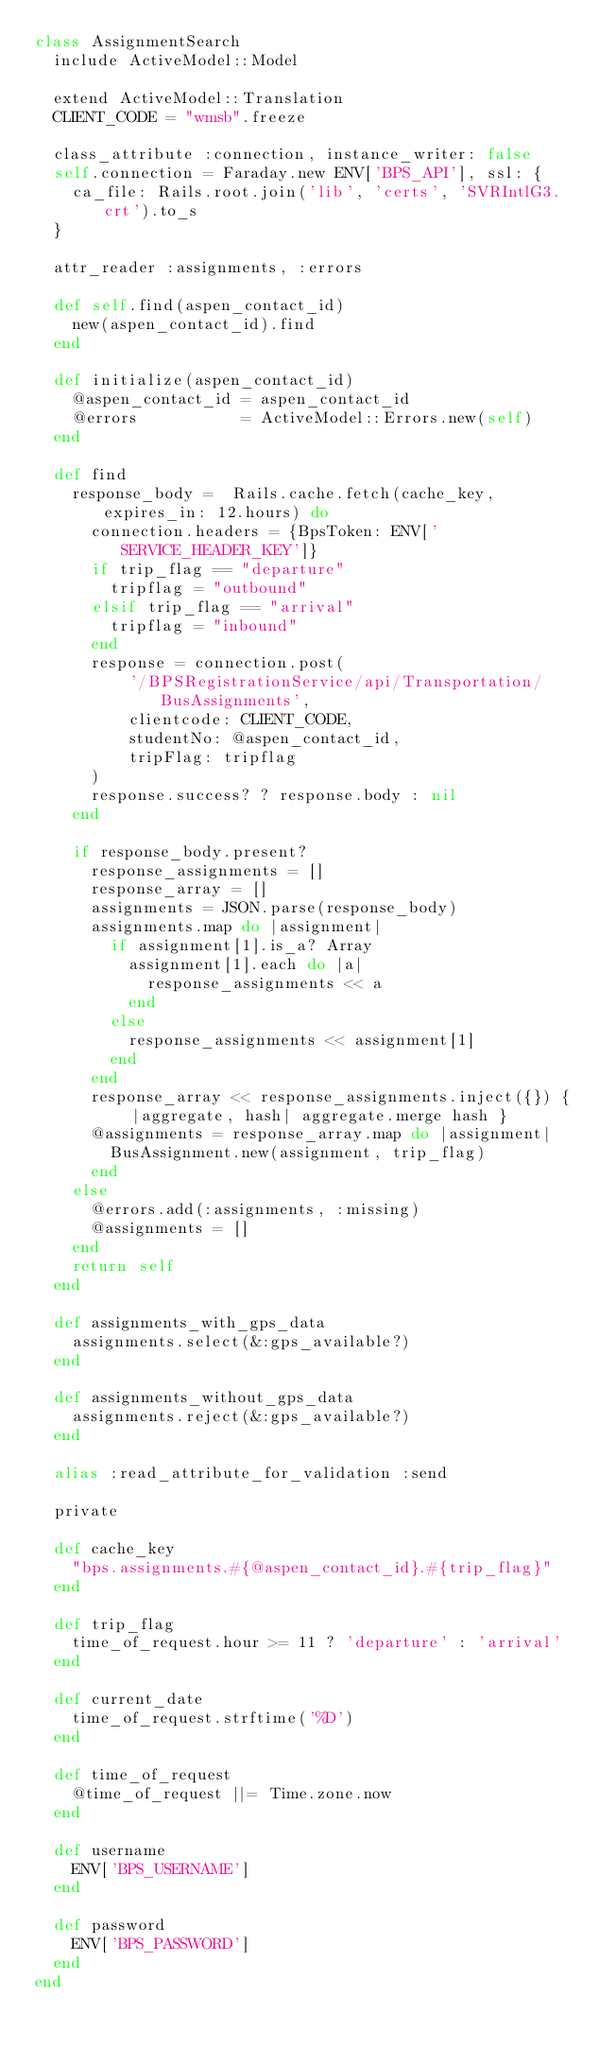Convert code to text. <code><loc_0><loc_0><loc_500><loc_500><_Ruby_>class AssignmentSearch
  include ActiveModel::Model

  extend ActiveModel::Translation
  CLIENT_CODE = "wmsb".freeze

  class_attribute :connection, instance_writer: false
  self.connection = Faraday.new ENV['BPS_API'], ssl: {
    ca_file: Rails.root.join('lib', 'certs', 'SVRIntlG3.crt').to_s
  }

  attr_reader :assignments, :errors

  def self.find(aspen_contact_id)
    new(aspen_contact_id).find
  end

  def initialize(aspen_contact_id)
    @aspen_contact_id = aspen_contact_id
    @errors           = ActiveModel::Errors.new(self)
  end

  def find
    response_body =  Rails.cache.fetch(cache_key, expires_in: 12.hours) do
      connection.headers = {BpsToken: ENV['SERVICE_HEADER_KEY']}
      if trip_flag == "departure"
        tripflag = "outbound"
      elsif trip_flag == "arrival"
        tripflag = "inbound"
      end
      response = connection.post(
          '/BPSRegistrationService/api/Transportation/BusAssignments',
          clientcode: CLIENT_CODE,
          studentNo: @aspen_contact_id,
          tripFlag: tripflag
      )
      response.success? ? response.body : nil
    end

    if response_body.present?
      response_assignments = []
      response_array = []
      assignments = JSON.parse(response_body)
      assignments.map do |assignment|
        if assignment[1].is_a? Array
          assignment[1].each do |a|
            response_assignments << a
          end
        else
          response_assignments << assignment[1]
        end
      end
      response_array << response_assignments.inject({}) { |aggregate, hash| aggregate.merge hash }
      @assignments = response_array.map do |assignment|
        BusAssignment.new(assignment, trip_flag)
      end
    else
      @errors.add(:assignments, :missing)
      @assignments = []
    end
    return self
  end

  def assignments_with_gps_data
    assignments.select(&:gps_available?)
  end

  def assignments_without_gps_data
    assignments.reject(&:gps_available?)
  end

  alias :read_attribute_for_validation :send

  private

  def cache_key
    "bps.assignments.#{@aspen_contact_id}.#{trip_flag}"
  end

  def trip_flag
    time_of_request.hour >= 11 ? 'departure' : 'arrival'
  end

  def current_date
    time_of_request.strftime('%D')
  end

  def time_of_request
    @time_of_request ||= Time.zone.now
  end

  def username
    ENV['BPS_USERNAME']
  end

  def password
    ENV['BPS_PASSWORD']
  end
end
</code> 